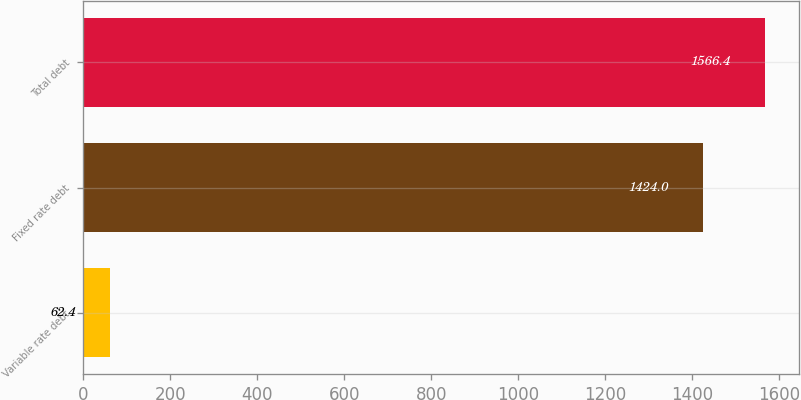Convert chart to OTSL. <chart><loc_0><loc_0><loc_500><loc_500><bar_chart><fcel>Variable rate debt<fcel>Fixed rate debt<fcel>Total debt<nl><fcel>62.4<fcel>1424<fcel>1566.4<nl></chart> 